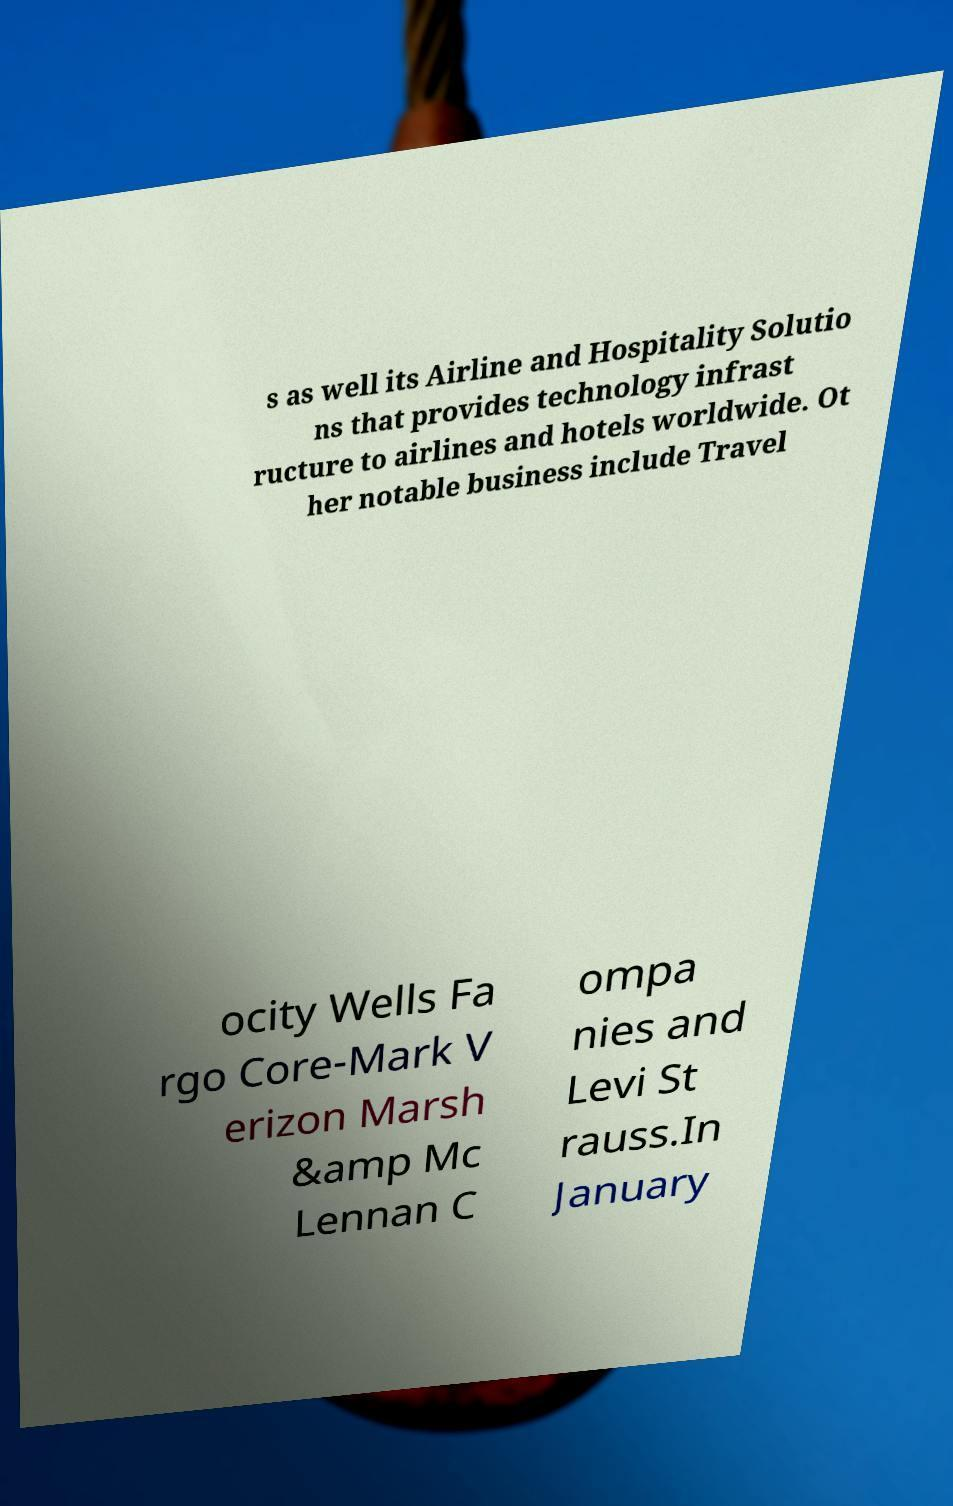For documentation purposes, I need the text within this image transcribed. Could you provide that? s as well its Airline and Hospitality Solutio ns that provides technology infrast ructure to airlines and hotels worldwide. Ot her notable business include Travel ocity Wells Fa rgo Core-Mark V erizon Marsh &amp Mc Lennan C ompa nies and Levi St rauss.In January 